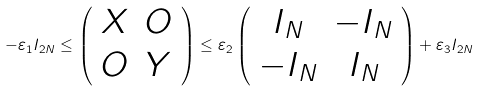Convert formula to latex. <formula><loc_0><loc_0><loc_500><loc_500>- \varepsilon _ { 1 } I _ { 2 N } \leq \left ( \begin{array} { c c } X & O \\ O & Y \end{array} \right ) \leq \varepsilon _ { 2 } \left ( \begin{array} { c c } I _ { N } & - I _ { N } \\ - I _ { N } & I _ { N } \end{array} \right ) + \varepsilon _ { 3 } I _ { 2 N }</formula> 